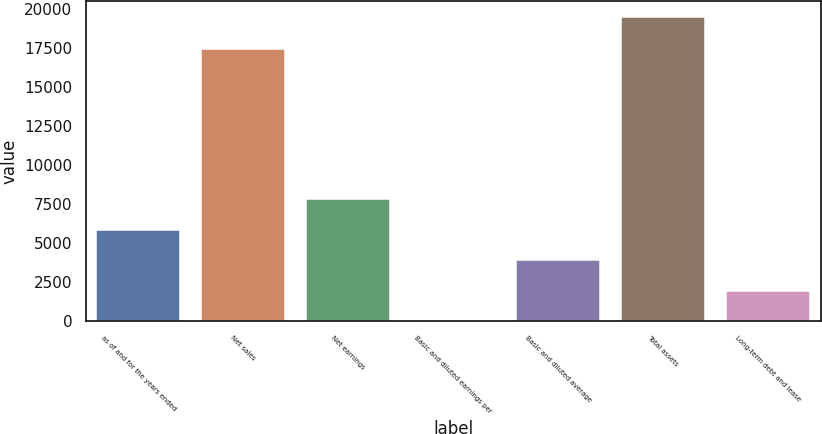<chart> <loc_0><loc_0><loc_500><loc_500><bar_chart><fcel>as of and for the years ended<fcel>Net sales<fcel>Net earnings<fcel>Basic and diluted earnings per<fcel>Basic and diluted average<fcel>Total assets<fcel>Long-term debt and lease<nl><fcel>5857.82<fcel>17444<fcel>7809.7<fcel>2.18<fcel>3905.94<fcel>19521<fcel>1954.06<nl></chart> 